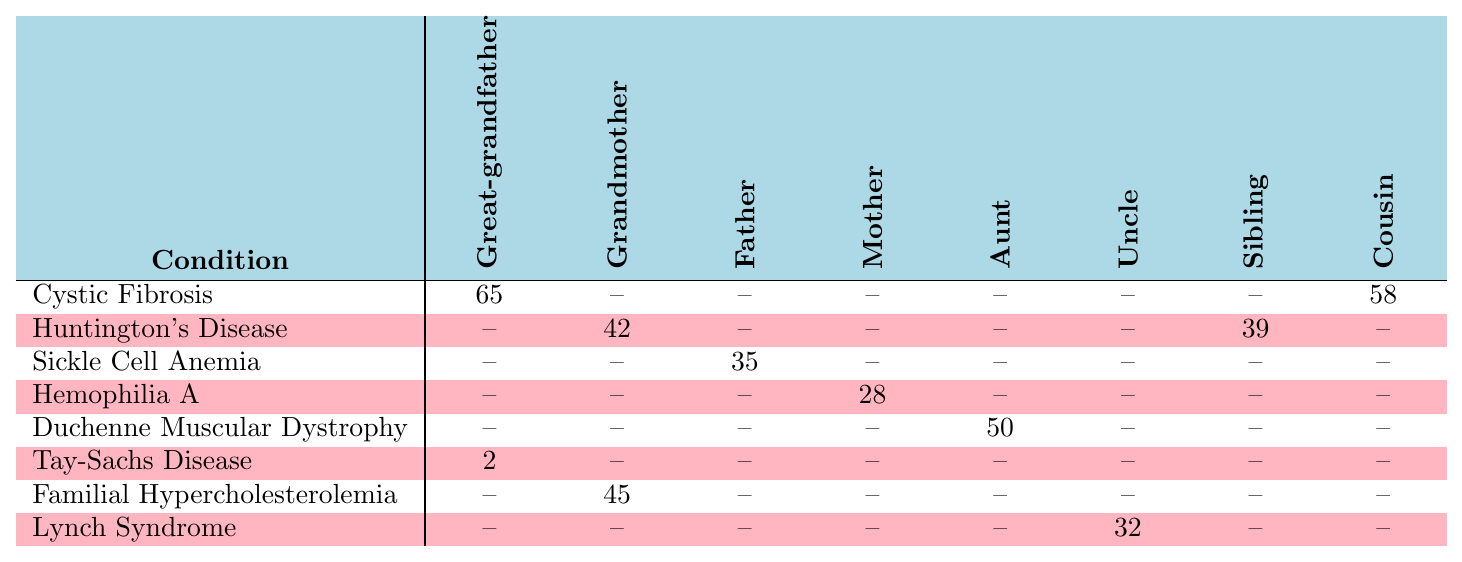What hereditary condition is present in the Great-grandfather? The table lists "Cystic Fibrosis" with an age of onset of 65 for the Great-grandfather.
Answer: Cystic Fibrosis What is the age of onset for Huntington's Disease in the Grandmother? The table shows that the age of onset for Huntington's Disease in the Grandmother is 42.
Answer: 42 Which condition has the youngest age of onset, and who has it? The youngest age of onset is 2 years for Tay-Sachs Disease, which is present in the Great-grandfather.
Answer: Tay-Sachs Disease, Great-grandfather Does the Uncle have any hereditary conditions listed in the table? The table indicates that the Uncle has Lynch Syndrome with an age of onset of 32.
Answer: Yes What is the average age of onset for all hereditary conditions listed? Adding the ages (65 + 42 + 35 + 28 + 50 + 2 + 45 + 32) gives a total of 299. There are 8 entries where the age is known, resulting in an average of 299/8 = 37.375.
Answer: 37.375 Which family member has the highest age of onset for any hereditary condition? The Great-grandfather has the highest age of onset for Cystic Fibrosis at 65 years.
Answer: Great-grandfather Is there any hereditary condition that affects both the Grandmother and the Sibling? The table shows that both the Grandmother and Sibling have Familial Hypercholesterolemia, but the Grandmother has it at age 45.
Answer: No What is the total number of hereditary conditions present in the Father? The table indicates that Sickle Cell Anemia is the only condition present in the Father.
Answer: 1 Which hereditary condition is present in both the Aunt and Cousin? The table shows that there are no shared conditions between the Aunt and Cousin.
Answer: None What is the age of onset difference between Hemophilia A and Sickle Cell Anemia? Hemophilia A has an age of onset of 28, while Sickle Cell Anemia has an age of 35. The difference is 35 - 28 = 7 years.
Answer: 7 years 